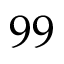<formula> <loc_0><loc_0><loc_500><loc_500>9 9</formula> 